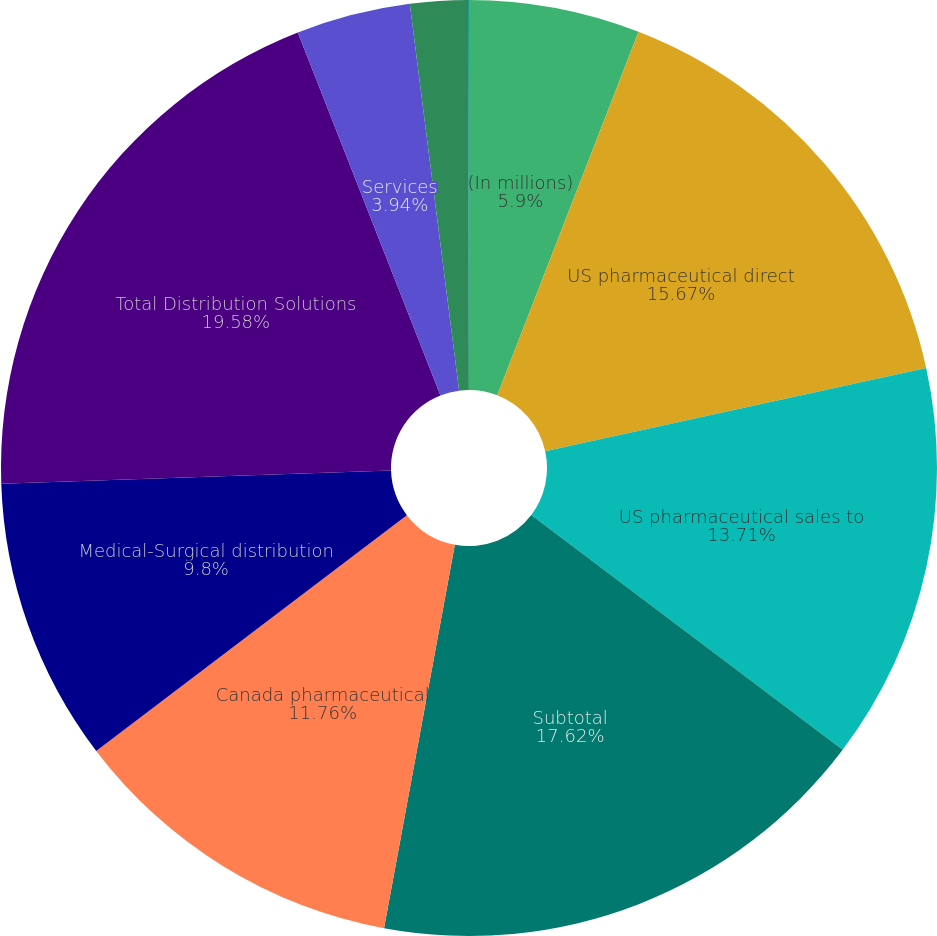Convert chart. <chart><loc_0><loc_0><loc_500><loc_500><pie_chart><fcel>(In millions)<fcel>US pharmaceutical direct<fcel>US pharmaceutical sales to<fcel>Subtotal<fcel>Canada pharmaceutical<fcel>Medical-Surgical distribution<fcel>Total Distribution Solutions<fcel>Services<fcel>Software and software systems<fcel>Hardware<nl><fcel>5.9%<fcel>15.67%<fcel>13.71%<fcel>17.62%<fcel>11.76%<fcel>9.8%<fcel>19.57%<fcel>3.94%<fcel>1.99%<fcel>0.03%<nl></chart> 